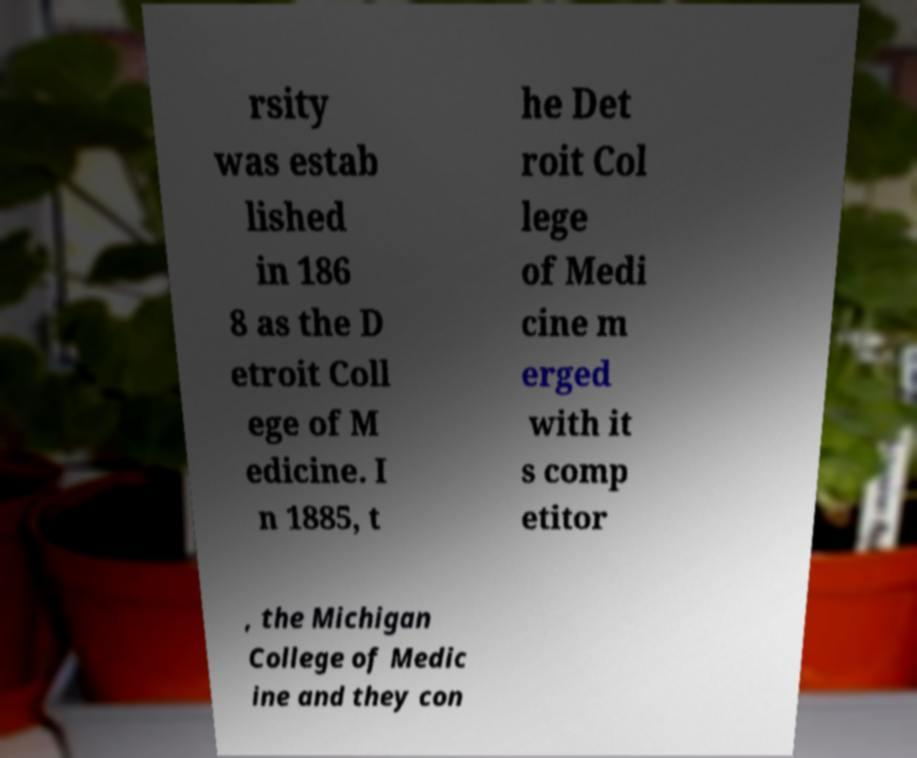For documentation purposes, I need the text within this image transcribed. Could you provide that? rsity was estab lished in 186 8 as the D etroit Coll ege of M edicine. I n 1885, t he Det roit Col lege of Medi cine m erged with it s comp etitor , the Michigan College of Medic ine and they con 